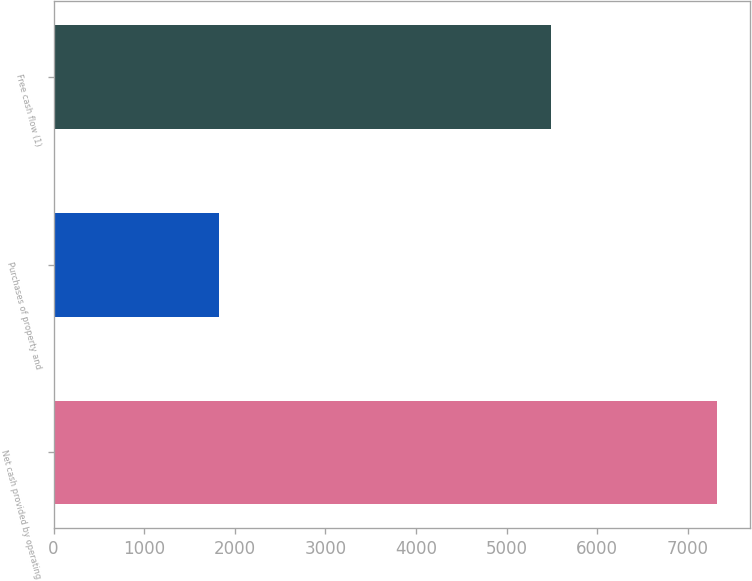<chart> <loc_0><loc_0><loc_500><loc_500><bar_chart><fcel>Net cash provided by operating<fcel>Purchases of property and<fcel>Free cash flow (1)<nl><fcel>7326<fcel>1831<fcel>5495<nl></chart> 